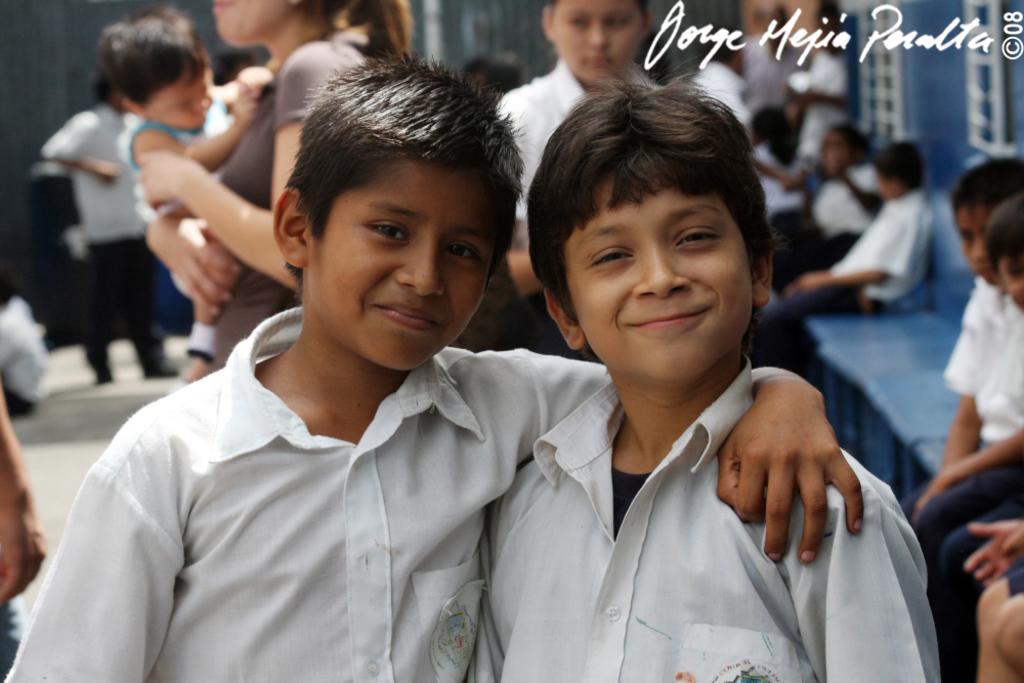How would you summarize this image in a sentence or two? In this picture we can see two boys smiling and in the background we can see a group of people where some are standing and some are sitting. 